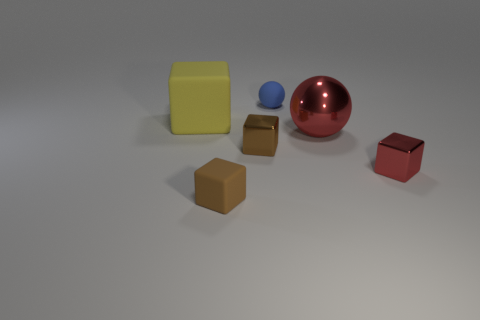There is a tiny shiny thing that is the same color as the large metallic object; what shape is it?
Make the answer very short. Cube. Is the red cube made of the same material as the small blue sphere?
Your answer should be very brief. No. Are there more red spheres behind the matte sphere than tiny green spheres?
Your answer should be compact. No. There is a cube in front of the tiny red cube in front of the rubber object that is to the left of the brown rubber thing; what is its material?
Offer a very short reply. Rubber. How many objects are large brown objects or tiny rubber things that are right of the small rubber block?
Your response must be concise. 1. There is a metallic object behind the brown metallic thing; is it the same color as the rubber ball?
Your response must be concise. No. Is the number of blocks in front of the red metal block greater than the number of small metal things on the left side of the yellow matte block?
Your answer should be very brief. Yes. Are there any other things that have the same color as the large ball?
Keep it short and to the point. Yes. What number of things are either brown matte blocks or large brown rubber blocks?
Keep it short and to the point. 1. Is the size of the brown block behind the brown rubber block the same as the small red metal thing?
Ensure brevity in your answer.  Yes. 